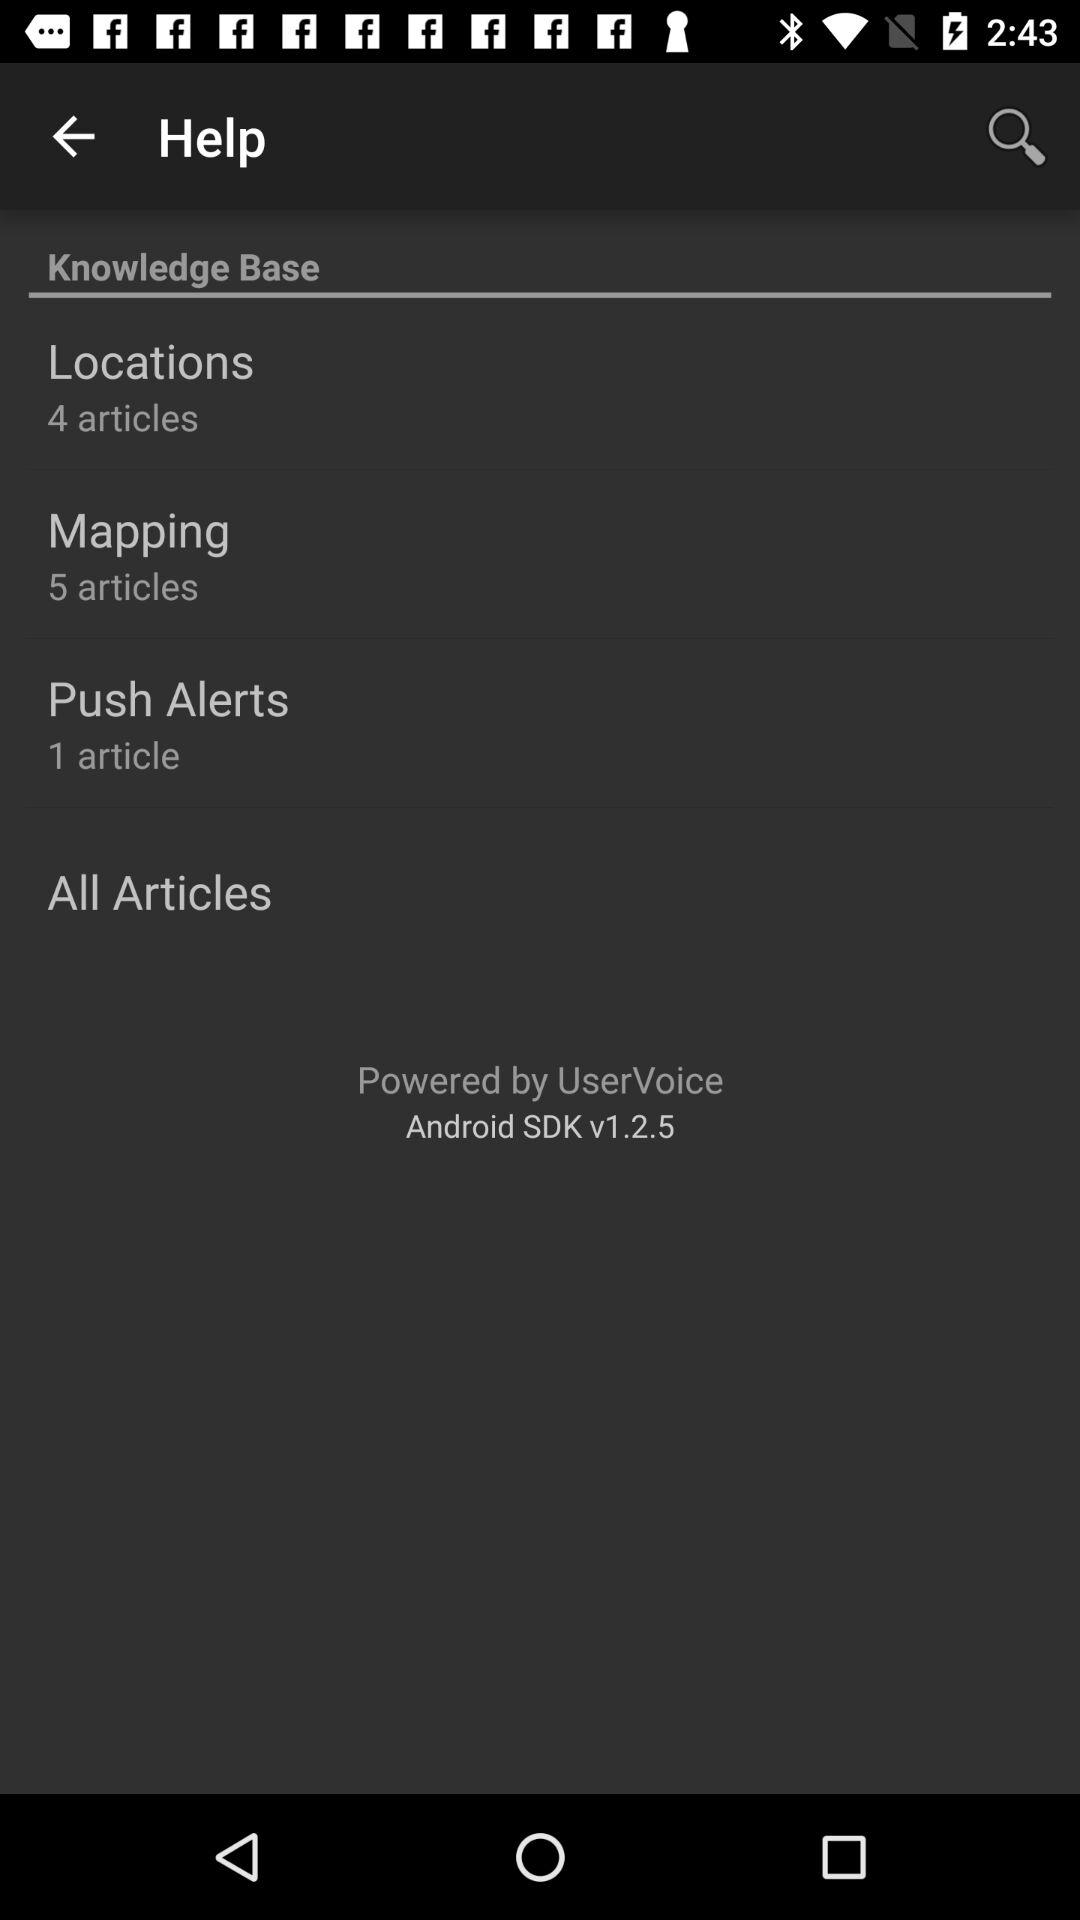What is the total number of articles in "Locations"? The total number of articles in "Locations" is 4. 